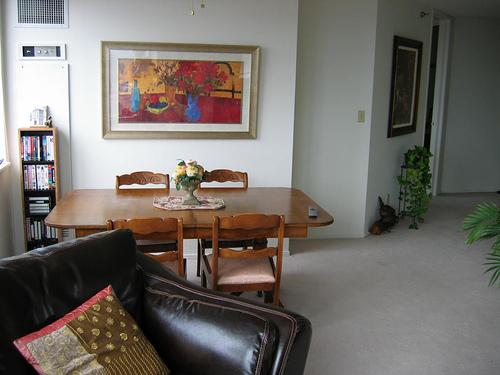How many green plants are in the room?
Write a very short answer. 2. What kind of plant is in the pot?
Be succinct. Houseplant. What material is the couch made of?
Concise answer only. Leather. What color vases do we see?
Give a very brief answer. Green. 